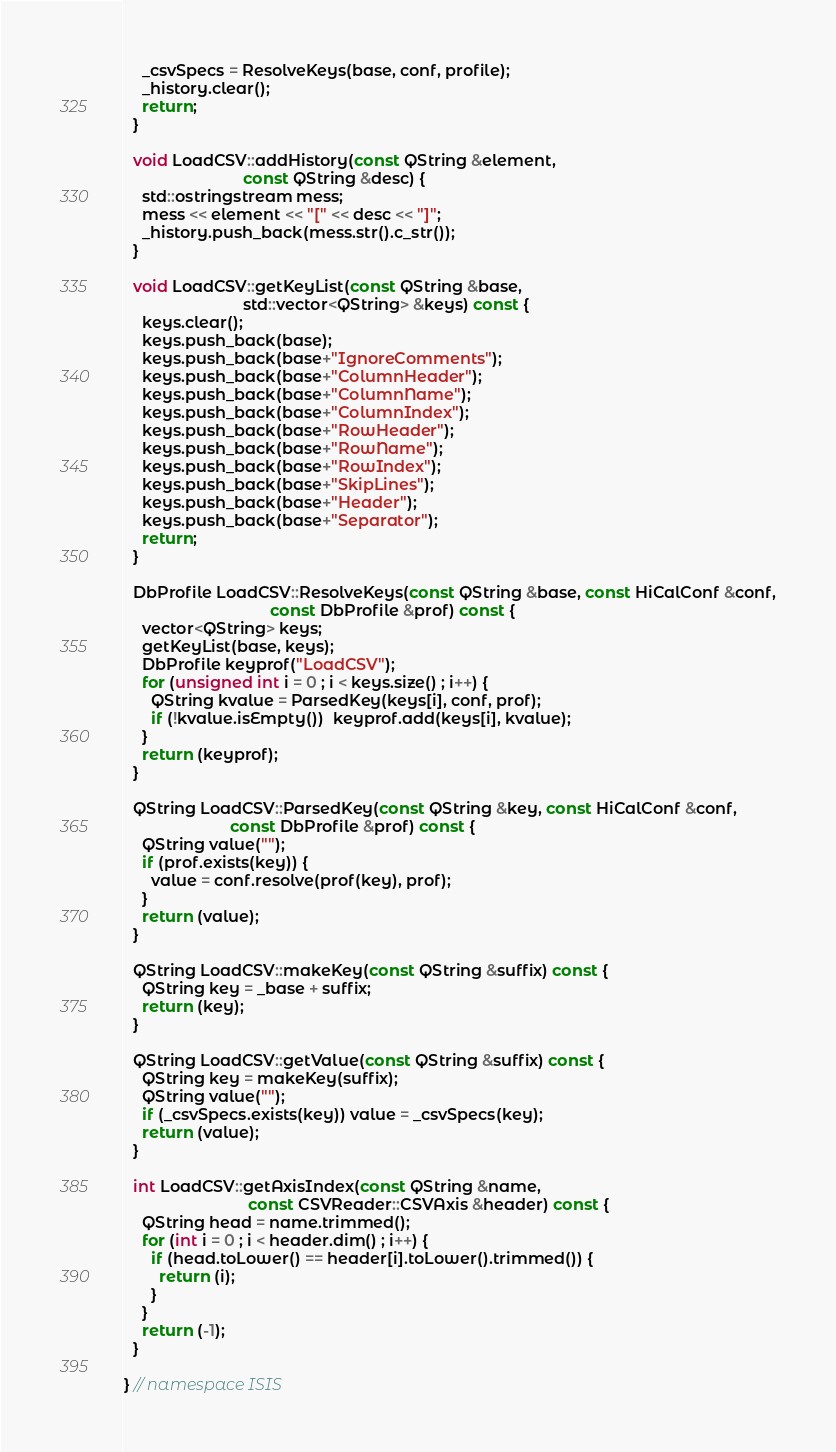Convert code to text. <code><loc_0><loc_0><loc_500><loc_500><_C++_>    _csvSpecs = ResolveKeys(base, conf, profile);
    _history.clear();
    return;
  }

  void LoadCSV::addHistory(const QString &element,
                           const QString &desc) {
    std::ostringstream mess;
    mess << element << "[" << desc << "]";
    _history.push_back(mess.str().c_str());
  }

  void LoadCSV::getKeyList(const QString &base,
                           std::vector<QString> &keys) const {
    keys.clear();
    keys.push_back(base);
    keys.push_back(base+"IgnoreComments");
    keys.push_back(base+"ColumnHeader");
    keys.push_back(base+"ColumnName");
    keys.push_back(base+"ColumnIndex");
    keys.push_back(base+"RowHeader");
    keys.push_back(base+"RowName");
    keys.push_back(base+"RowIndex");
    keys.push_back(base+"SkipLines");
    keys.push_back(base+"Header");
    keys.push_back(base+"Separator");
    return;
  }

  DbProfile LoadCSV::ResolveKeys(const QString &base, const HiCalConf &conf,
                                 const DbProfile &prof) const {
    vector<QString> keys;
    getKeyList(base, keys);
    DbProfile keyprof("LoadCSV");
    for (unsigned int i = 0 ; i < keys.size() ; i++) {
      QString kvalue = ParsedKey(keys[i], conf, prof);
      if (!kvalue.isEmpty())  keyprof.add(keys[i], kvalue);
    }
    return (keyprof);
  }

  QString LoadCSV::ParsedKey(const QString &key, const HiCalConf &conf,
                        const DbProfile &prof) const {
    QString value("");
    if (prof.exists(key)) {
      value = conf.resolve(prof(key), prof);
    }
    return (value);
  }

  QString LoadCSV::makeKey(const QString &suffix) const {
    QString key = _base + suffix;
    return (key);
  }

  QString LoadCSV::getValue(const QString &suffix) const {
    QString key = makeKey(suffix);
    QString value("");
    if (_csvSpecs.exists(key)) value = _csvSpecs(key);
    return (value);
  }

  int LoadCSV::getAxisIndex(const QString &name,
                            const CSVReader::CSVAxis &header) const {
    QString head = name.trimmed();
    for (int i = 0 ; i < header.dim() ; i++) {
      if (head.toLower() == header[i].toLower().trimmed()) {
        return (i);
      }
    }
    return (-1);
  }

} // namespace ISIS
</code> 